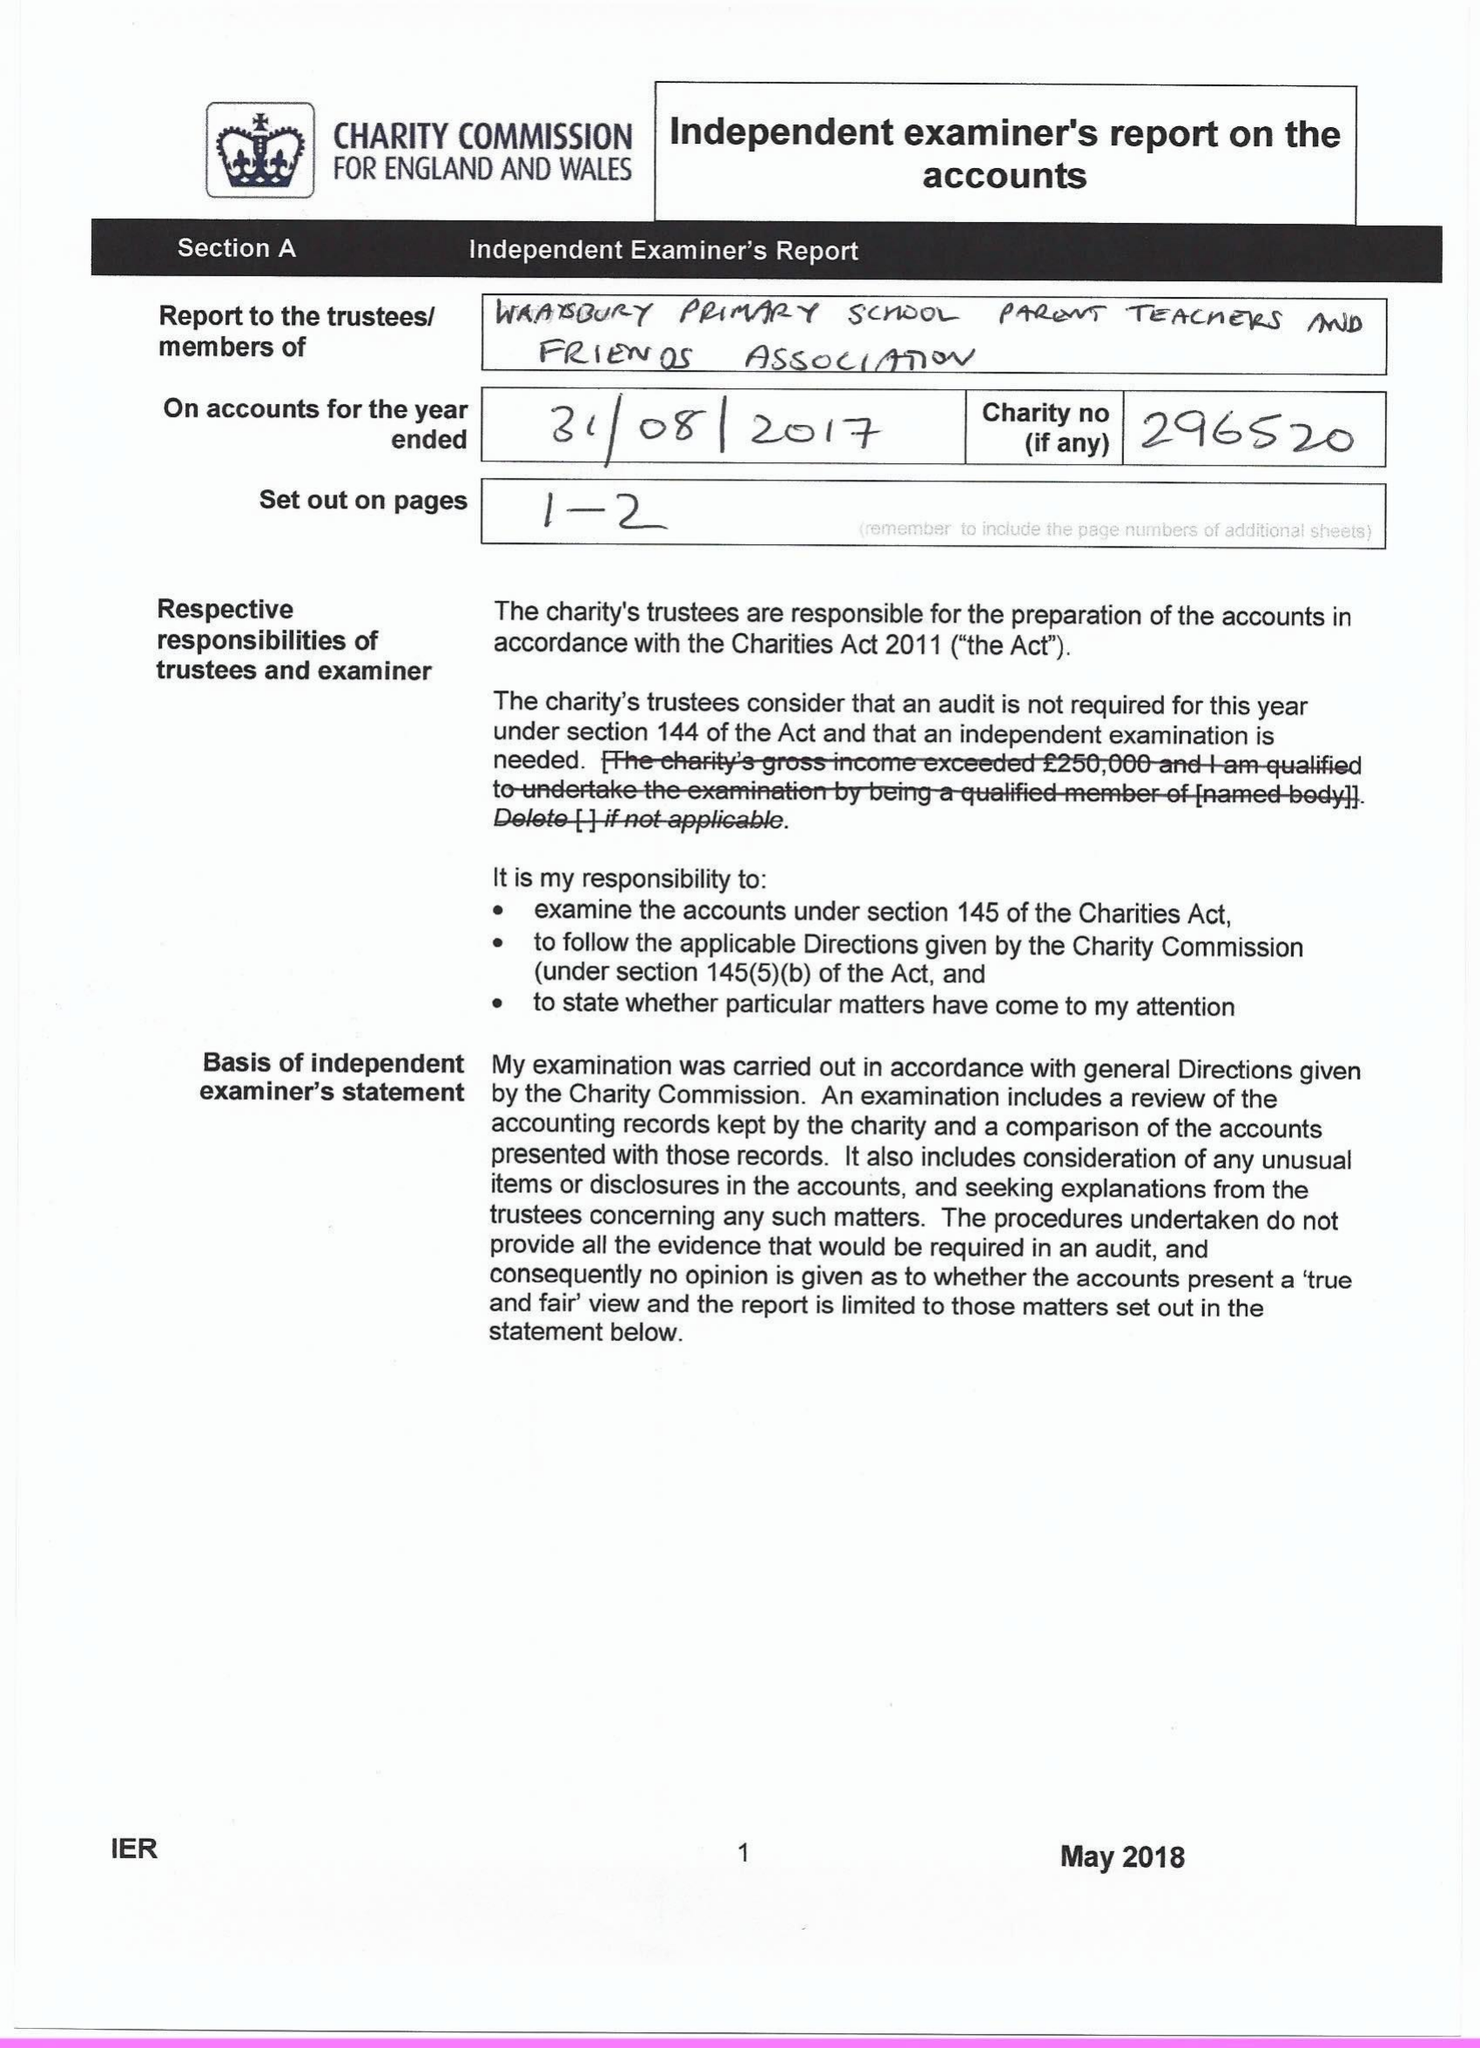What is the value for the charity_number?
Answer the question using a single word or phrase. 296520 